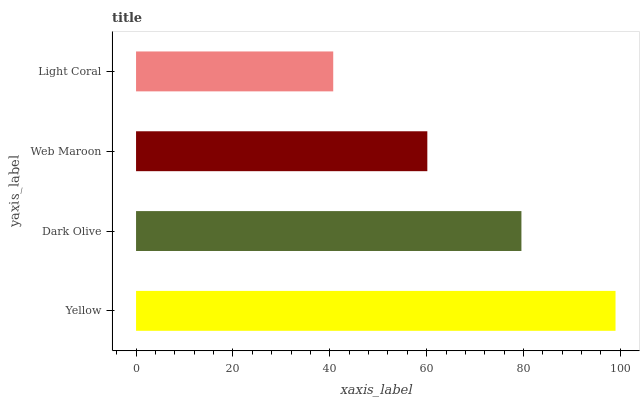Is Light Coral the minimum?
Answer yes or no. Yes. Is Yellow the maximum?
Answer yes or no. Yes. Is Dark Olive the minimum?
Answer yes or no. No. Is Dark Olive the maximum?
Answer yes or no. No. Is Yellow greater than Dark Olive?
Answer yes or no. Yes. Is Dark Olive less than Yellow?
Answer yes or no. Yes. Is Dark Olive greater than Yellow?
Answer yes or no. No. Is Yellow less than Dark Olive?
Answer yes or no. No. Is Dark Olive the high median?
Answer yes or no. Yes. Is Web Maroon the low median?
Answer yes or no. Yes. Is Web Maroon the high median?
Answer yes or no. No. Is Light Coral the low median?
Answer yes or no. No. 